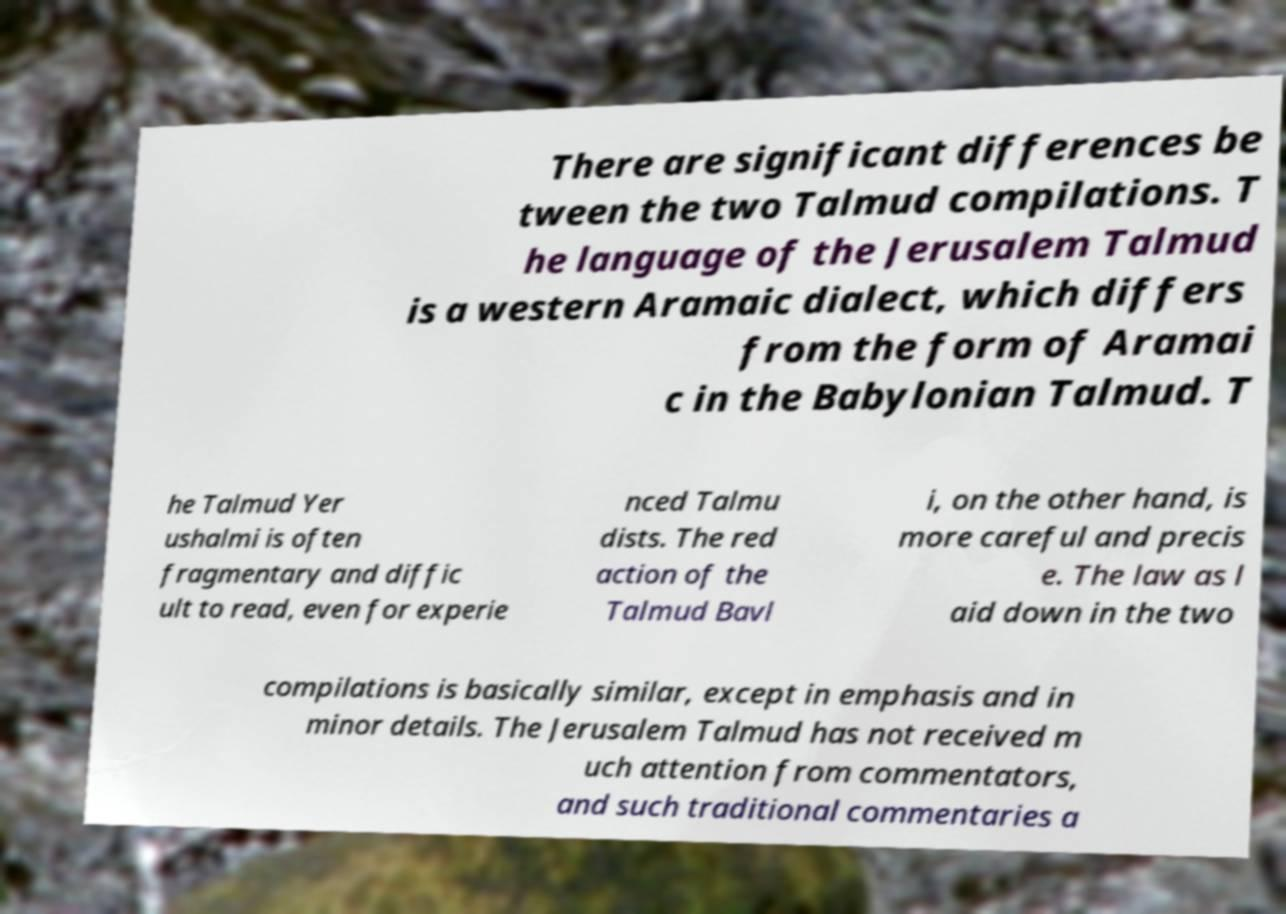Could you extract and type out the text from this image? There are significant differences be tween the two Talmud compilations. T he language of the Jerusalem Talmud is a western Aramaic dialect, which differs from the form of Aramai c in the Babylonian Talmud. T he Talmud Yer ushalmi is often fragmentary and diffic ult to read, even for experie nced Talmu dists. The red action of the Talmud Bavl i, on the other hand, is more careful and precis e. The law as l aid down in the two compilations is basically similar, except in emphasis and in minor details. The Jerusalem Talmud has not received m uch attention from commentators, and such traditional commentaries a 